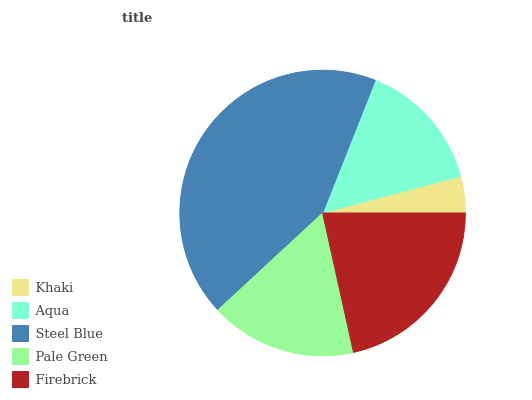Is Khaki the minimum?
Answer yes or no. Yes. Is Steel Blue the maximum?
Answer yes or no. Yes. Is Aqua the minimum?
Answer yes or no. No. Is Aqua the maximum?
Answer yes or no. No. Is Aqua greater than Khaki?
Answer yes or no. Yes. Is Khaki less than Aqua?
Answer yes or no. Yes. Is Khaki greater than Aqua?
Answer yes or no. No. Is Aqua less than Khaki?
Answer yes or no. No. Is Pale Green the high median?
Answer yes or no. Yes. Is Pale Green the low median?
Answer yes or no. Yes. Is Khaki the high median?
Answer yes or no. No. Is Aqua the low median?
Answer yes or no. No. 